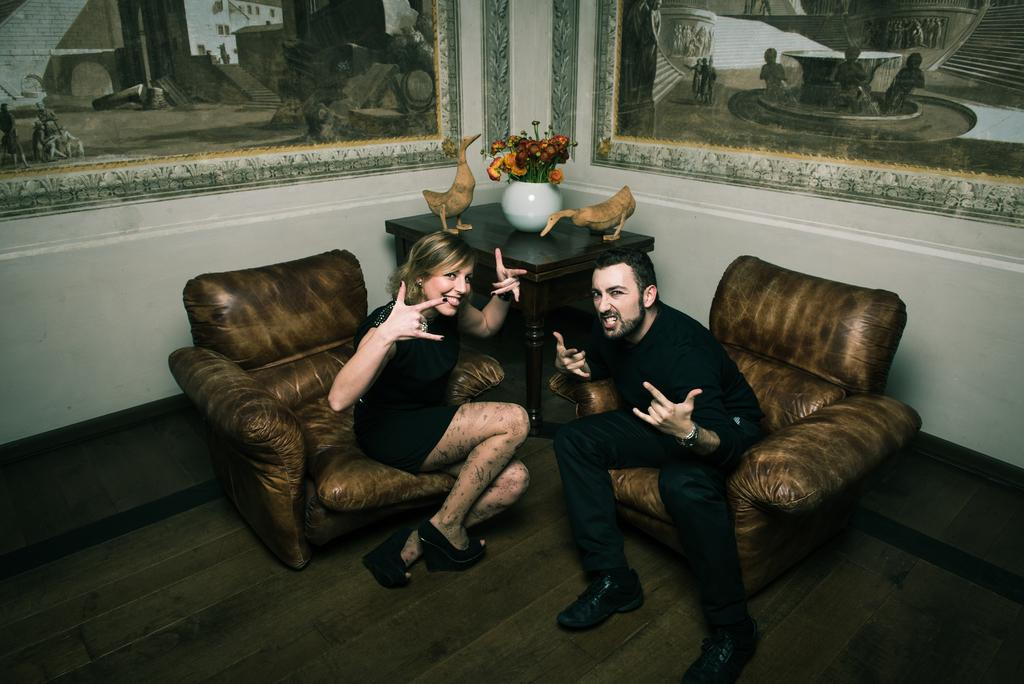How many people are in the image? There are two people in the image. What are the people wearing? The people are wearing black dresses. What are the people doing in the image? The people are sitting on sofas. What can be seen on the walls in the room? There are two wall posters in the room. What furniture is present in the room? There is a table in the room. What is on the table? There is a flower vase on the table. What type of territory is being claimed by the duck in the image? There is no duck present in the image, so no territory is being claimed. 